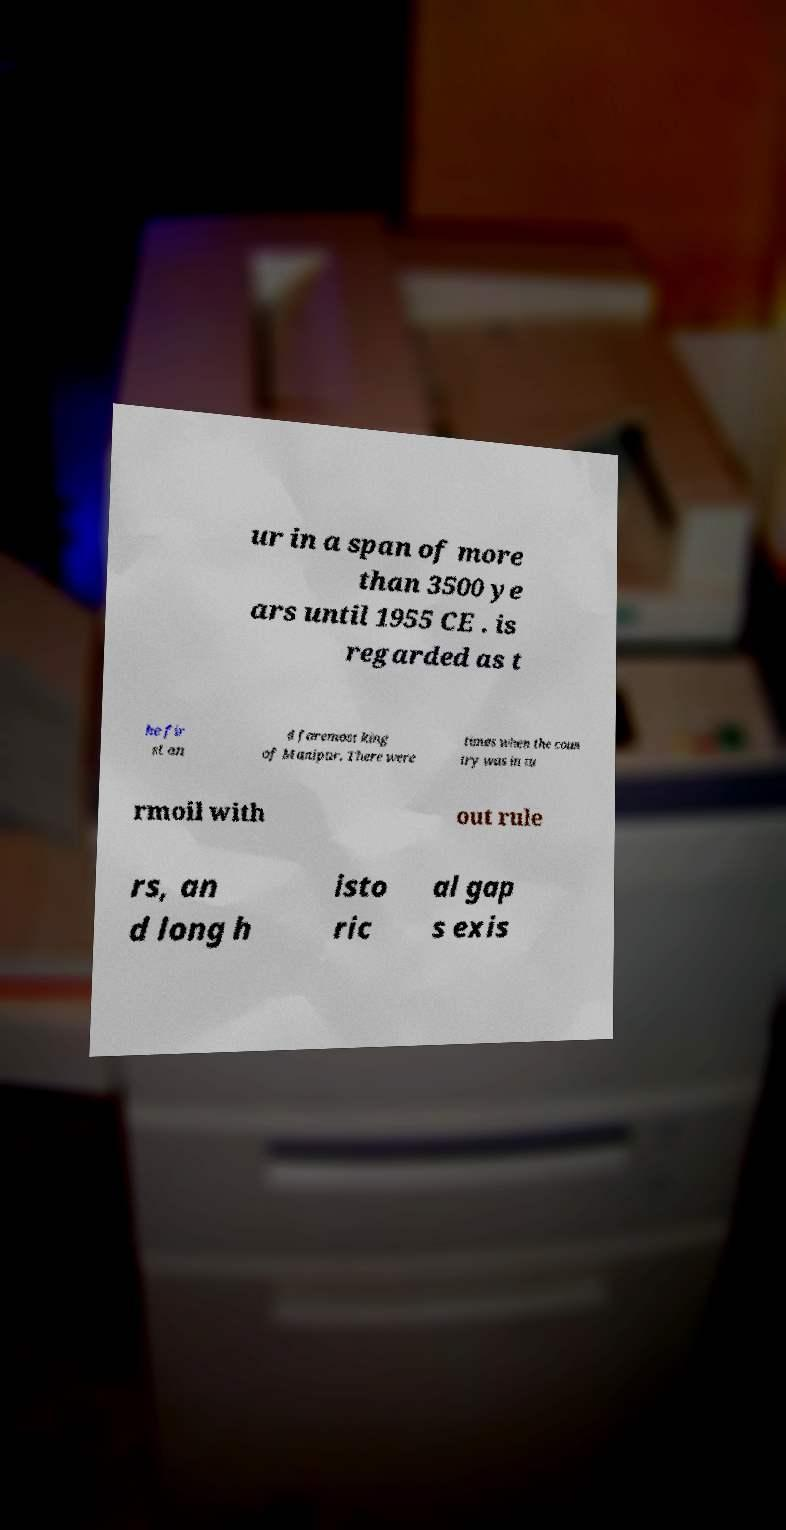What messages or text are displayed in this image? I need them in a readable, typed format. ur in a span of more than 3500 ye ars until 1955 CE . is regarded as t he fir st an d foremost king of Manipur. There were times when the coun try was in tu rmoil with out rule rs, an d long h isto ric al gap s exis 